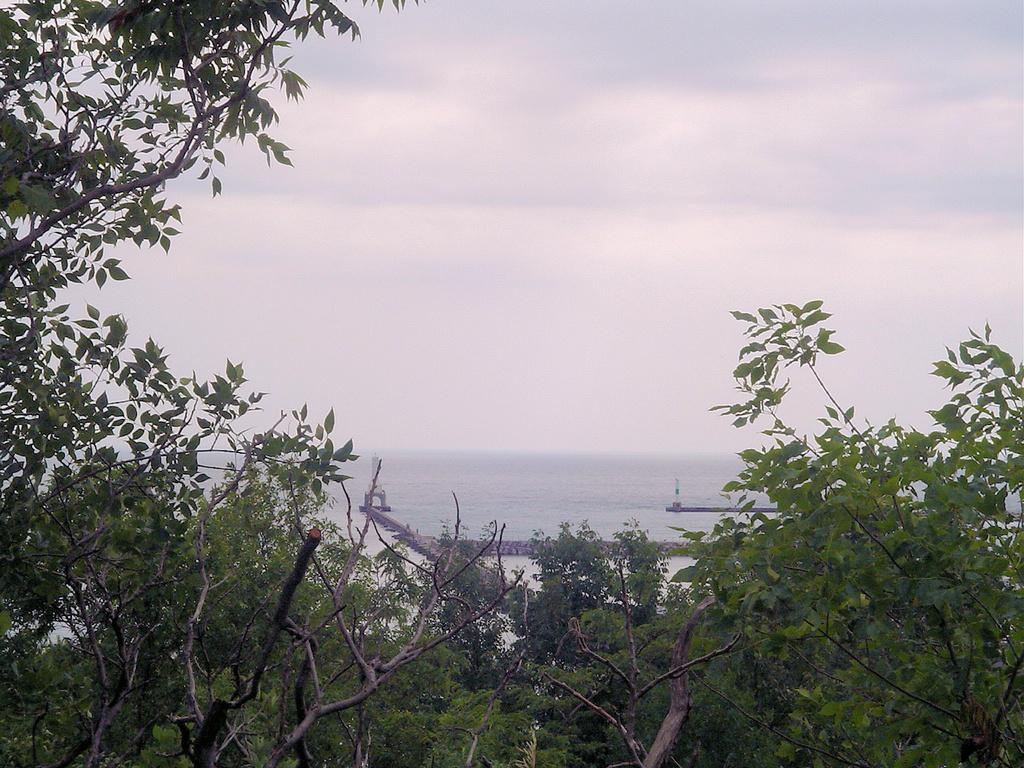What type of vegetation can be seen in the image? There are trees in the image. What natural element is visible besides the trees? There is water visible in the image. How would you describe the sky in the image? The sky appears to be cloudy. What type of wire can be seen connecting the trees in the image? There is no wire connecting the trees in the image; only the trees, water, and cloudy sky are present. 